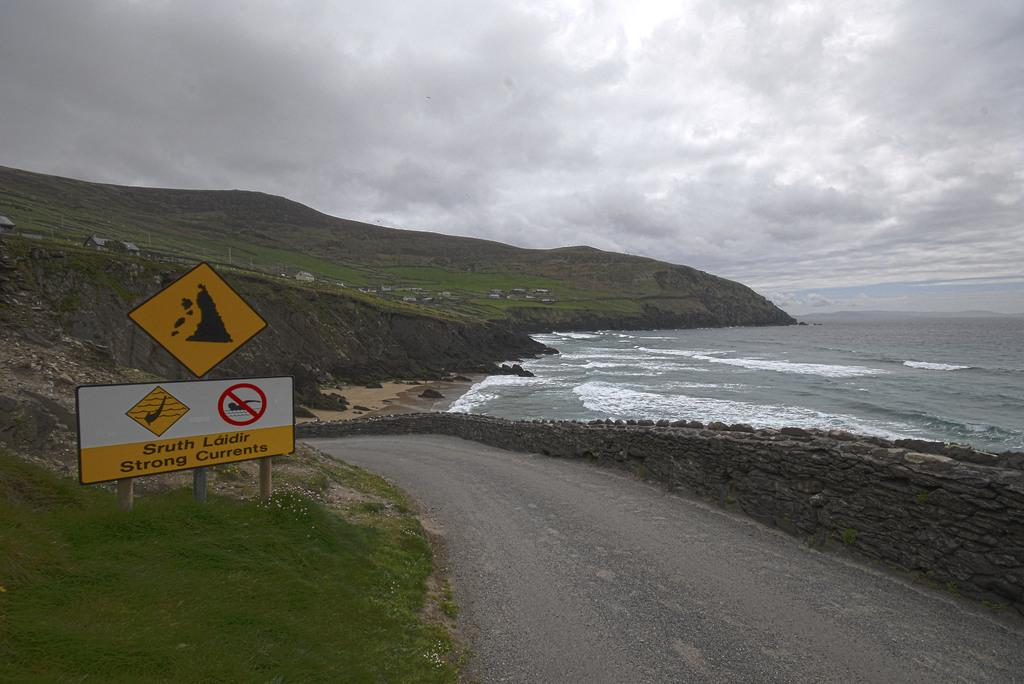<image>
Render a clear and concise summary of the photo. A sign warning of strong currents in the area. 